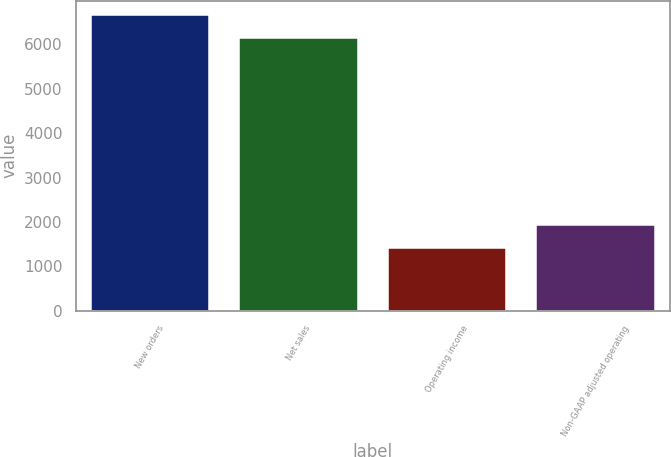Convert chart to OTSL. <chart><loc_0><loc_0><loc_500><loc_500><bar_chart><fcel>New orders<fcel>Net sales<fcel>Operating income<fcel>Non-GAAP adjusted operating<nl><fcel>6652.1<fcel>6135<fcel>1410<fcel>1927.1<nl></chart> 